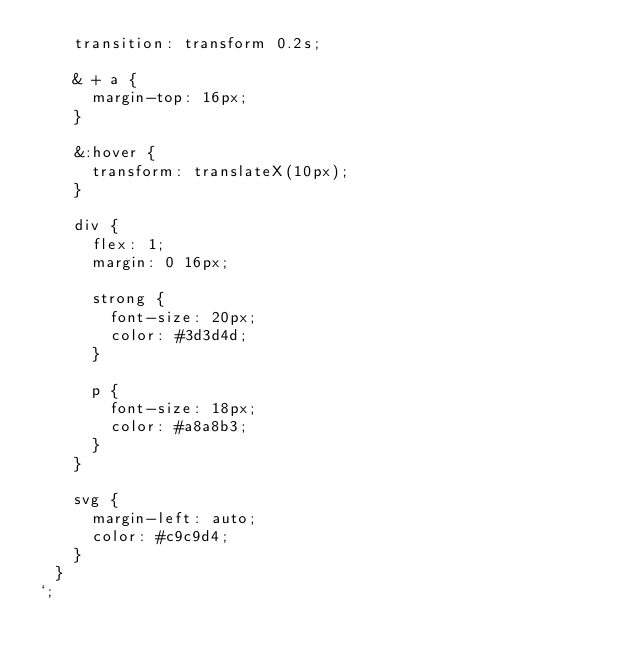Convert code to text. <code><loc_0><loc_0><loc_500><loc_500><_TypeScript_>    transition: transform 0.2s;

    & + a {
      margin-top: 16px;
    }

    &:hover {
      transform: translateX(10px);
    }

    div {
      flex: 1;
      margin: 0 16px;

      strong {
        font-size: 20px;
        color: #3d3d4d;
      }

      p {
        font-size: 18px;
        color: #a8a8b3;
      }
    }

    svg {
      margin-left: auto;
      color: #c9c9d4;
    }
  }
`;
</code> 